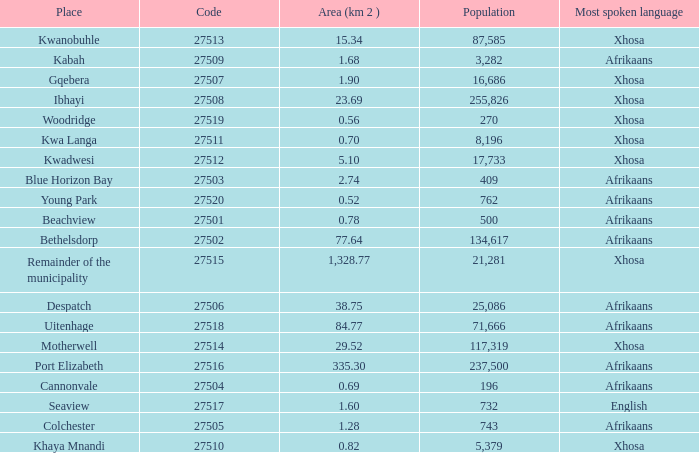What is the total number of area listed for cannonvale with a population less than 409? 1.0. 